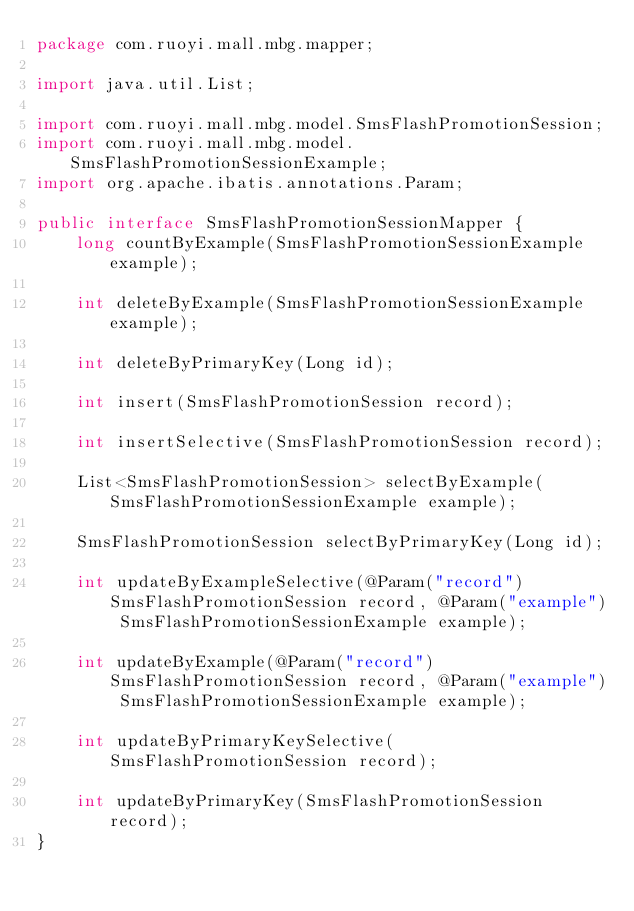Convert code to text. <code><loc_0><loc_0><loc_500><loc_500><_Java_>package com.ruoyi.mall.mbg.mapper;

import java.util.List;

import com.ruoyi.mall.mbg.model.SmsFlashPromotionSession;
import com.ruoyi.mall.mbg.model.SmsFlashPromotionSessionExample;
import org.apache.ibatis.annotations.Param;

public interface SmsFlashPromotionSessionMapper {
    long countByExample(SmsFlashPromotionSessionExample example);

    int deleteByExample(SmsFlashPromotionSessionExample example);

    int deleteByPrimaryKey(Long id);

    int insert(SmsFlashPromotionSession record);

    int insertSelective(SmsFlashPromotionSession record);

    List<SmsFlashPromotionSession> selectByExample(SmsFlashPromotionSessionExample example);

    SmsFlashPromotionSession selectByPrimaryKey(Long id);

    int updateByExampleSelective(@Param("record") SmsFlashPromotionSession record, @Param("example") SmsFlashPromotionSessionExample example);

    int updateByExample(@Param("record") SmsFlashPromotionSession record, @Param("example") SmsFlashPromotionSessionExample example);

    int updateByPrimaryKeySelective(SmsFlashPromotionSession record);

    int updateByPrimaryKey(SmsFlashPromotionSession record);
}</code> 